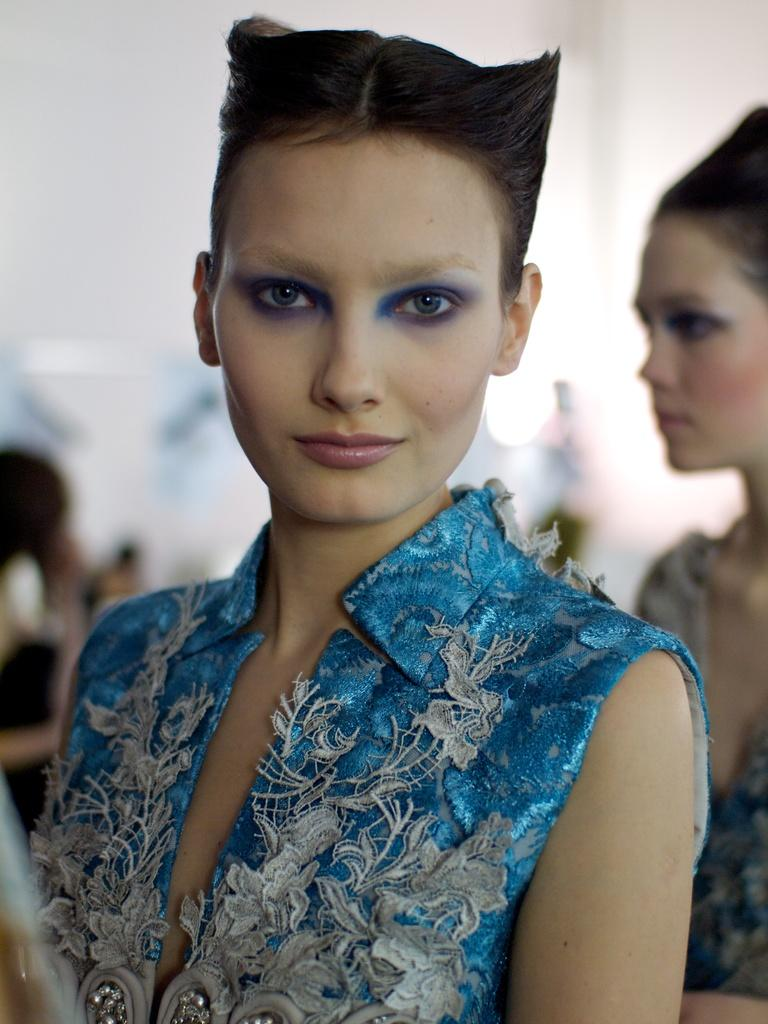Who is the main subject in the image? There is a woman in the image. What is the woman wearing? The woman is wearing a blue dress. Can you describe the background of the image? The background of the image is blurred. What is the woman teaching in the image? There is no indication in the image that the woman is teaching anything. How does the woman fall in the image? There is no woman falling in the image; she is standing. Where is the harbor located in the image? There is no harbor present in the image. 